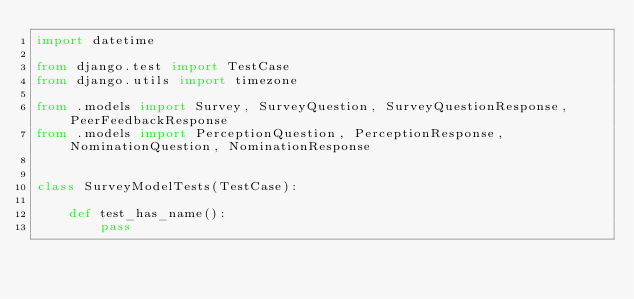Convert code to text. <code><loc_0><loc_0><loc_500><loc_500><_Python_>import datetime

from django.test import TestCase
from django.utils import timezone

from .models import Survey, SurveyQuestion, SurveyQuestionResponse, PeerFeedbackResponse
from .models import PerceptionQuestion, PerceptionResponse, NominationQuestion, NominationResponse


class SurveyModelTests(TestCase):

    def test_has_name():
        pass</code> 